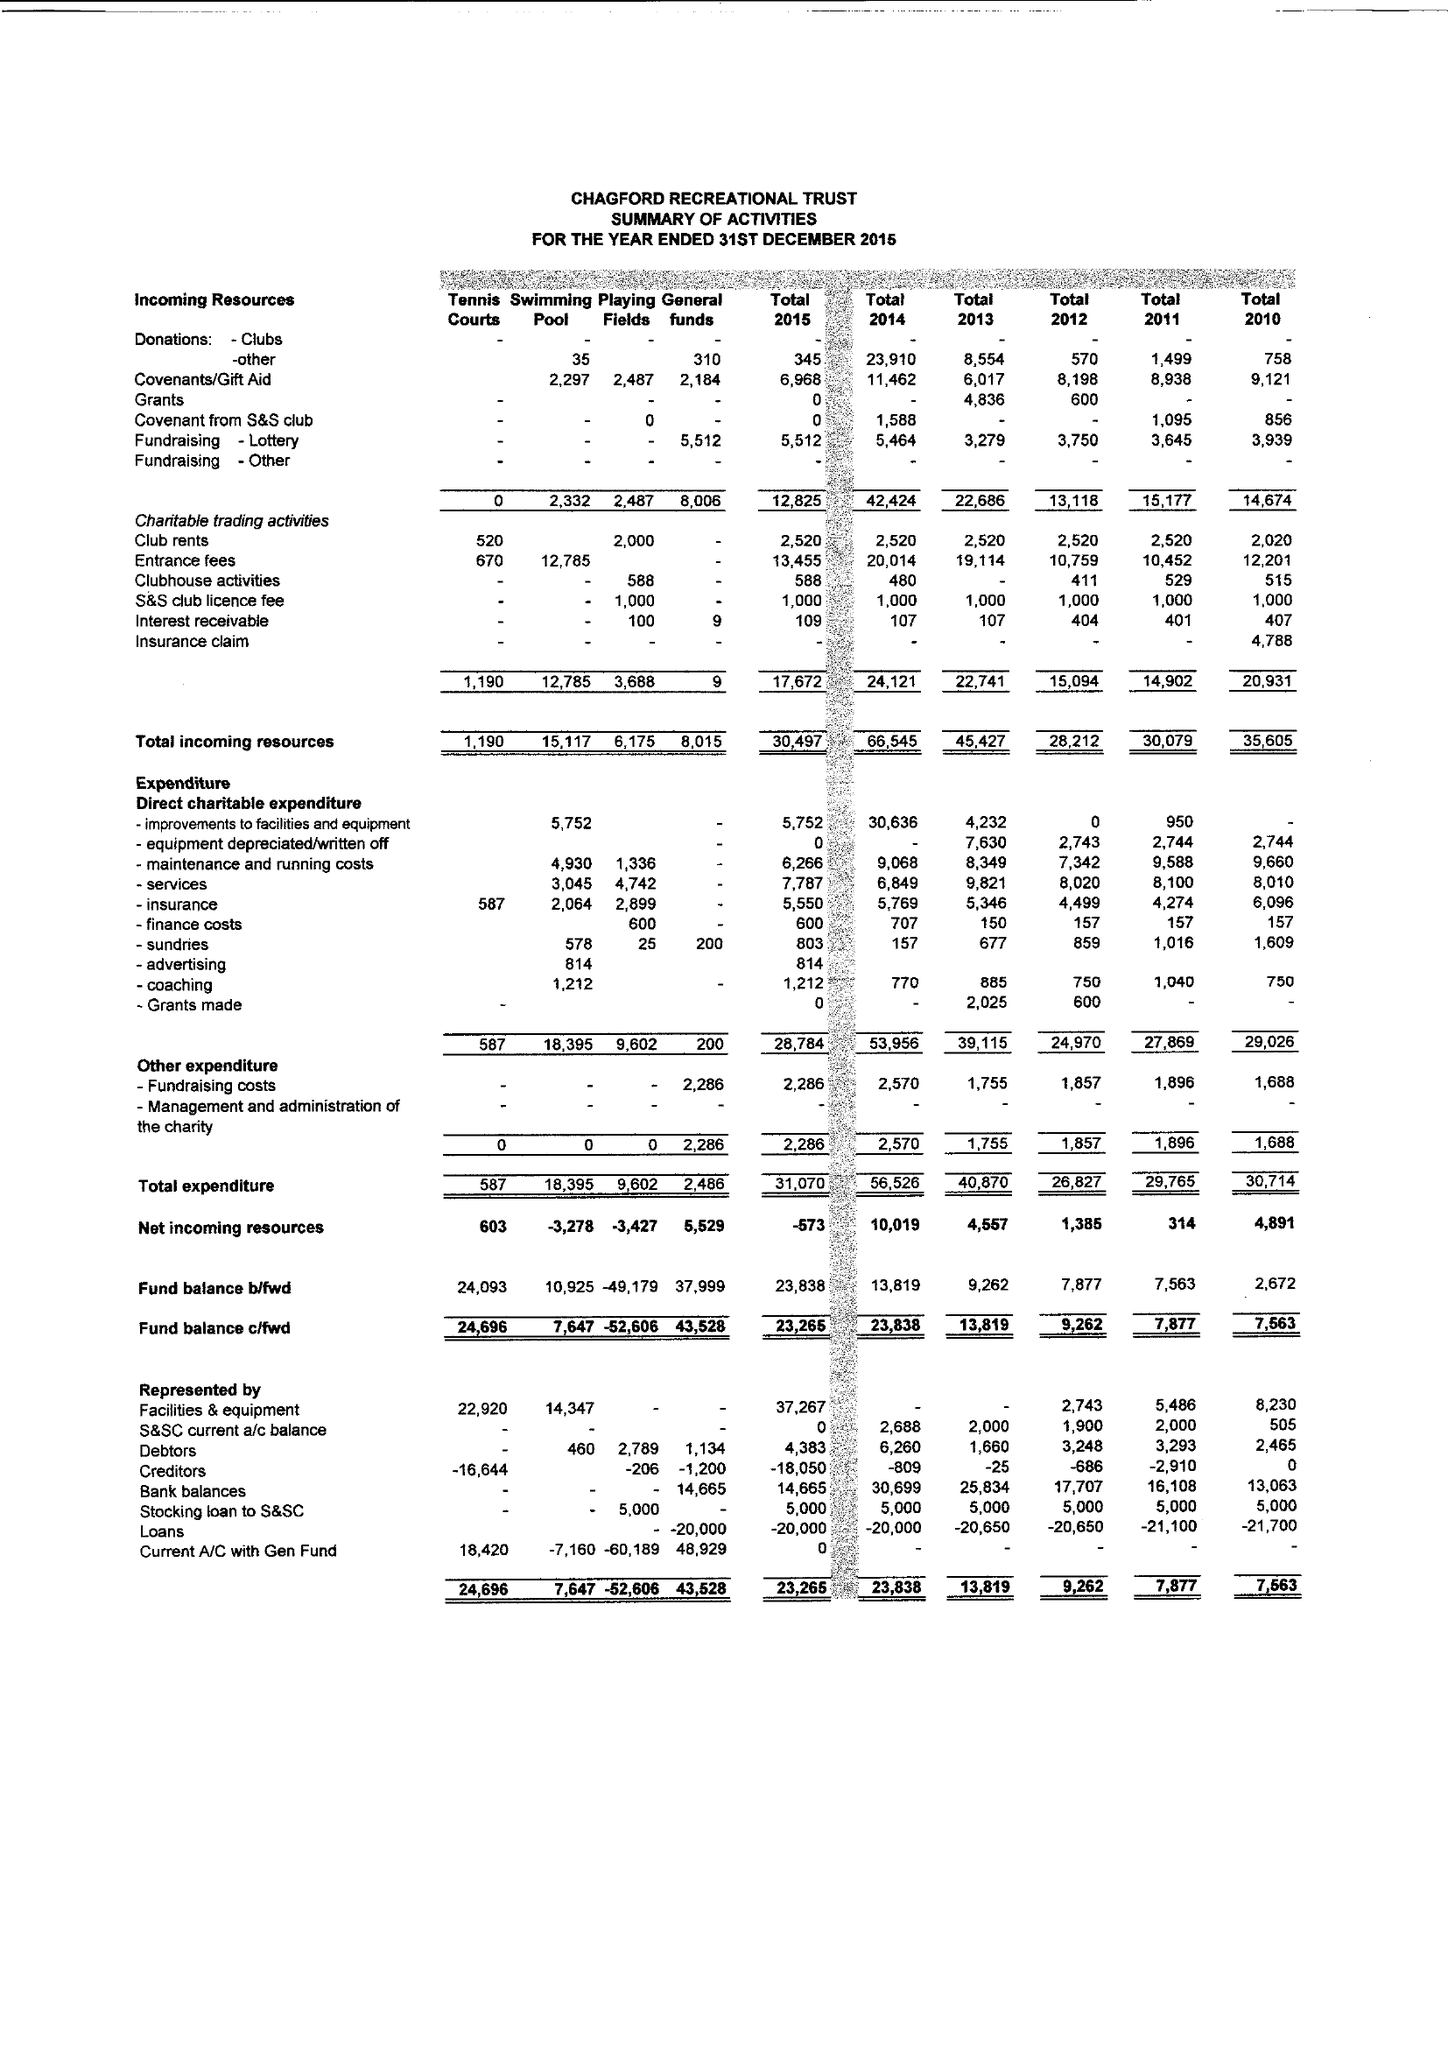What is the value for the report_date?
Answer the question using a single word or phrase. 2015-12-31 